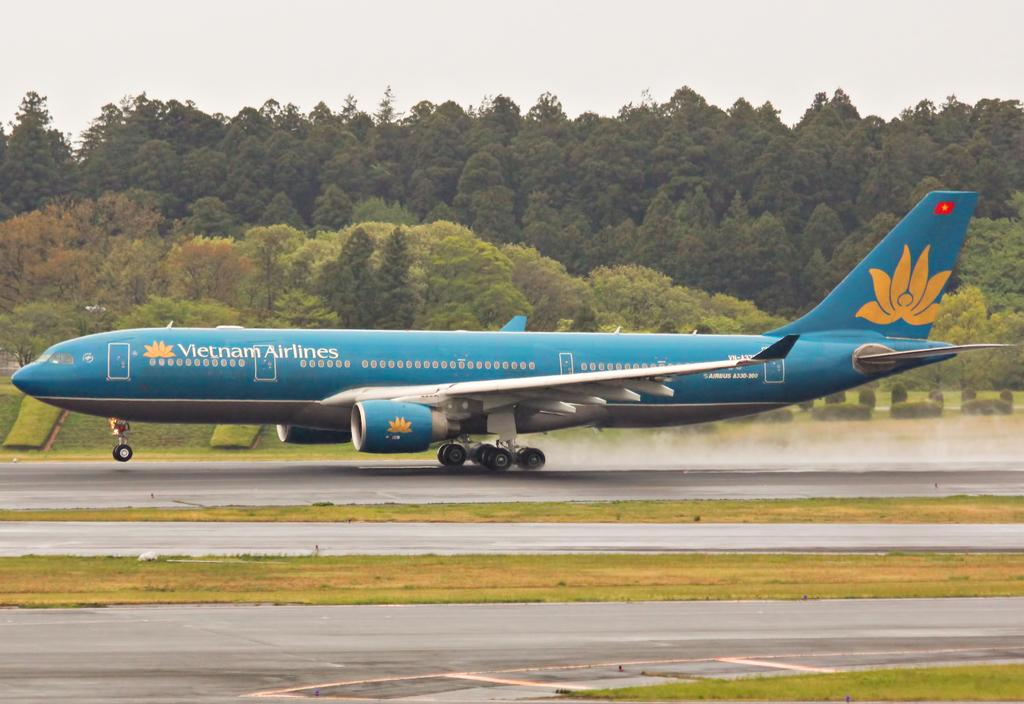What is the main subject of the image? The main subject of the image is an airplane. Where is the airplane located in the image? The airplane is in the center of the image. What can be seen in the background of the image? There are trees in the background of the image. How many pets are visible in the image? There are no pets visible in the image; it features an airplane and trees in the background. What type of instrument is being played in the image? There is no instrument being played in the image; it only shows an airplane and trees in the background. 